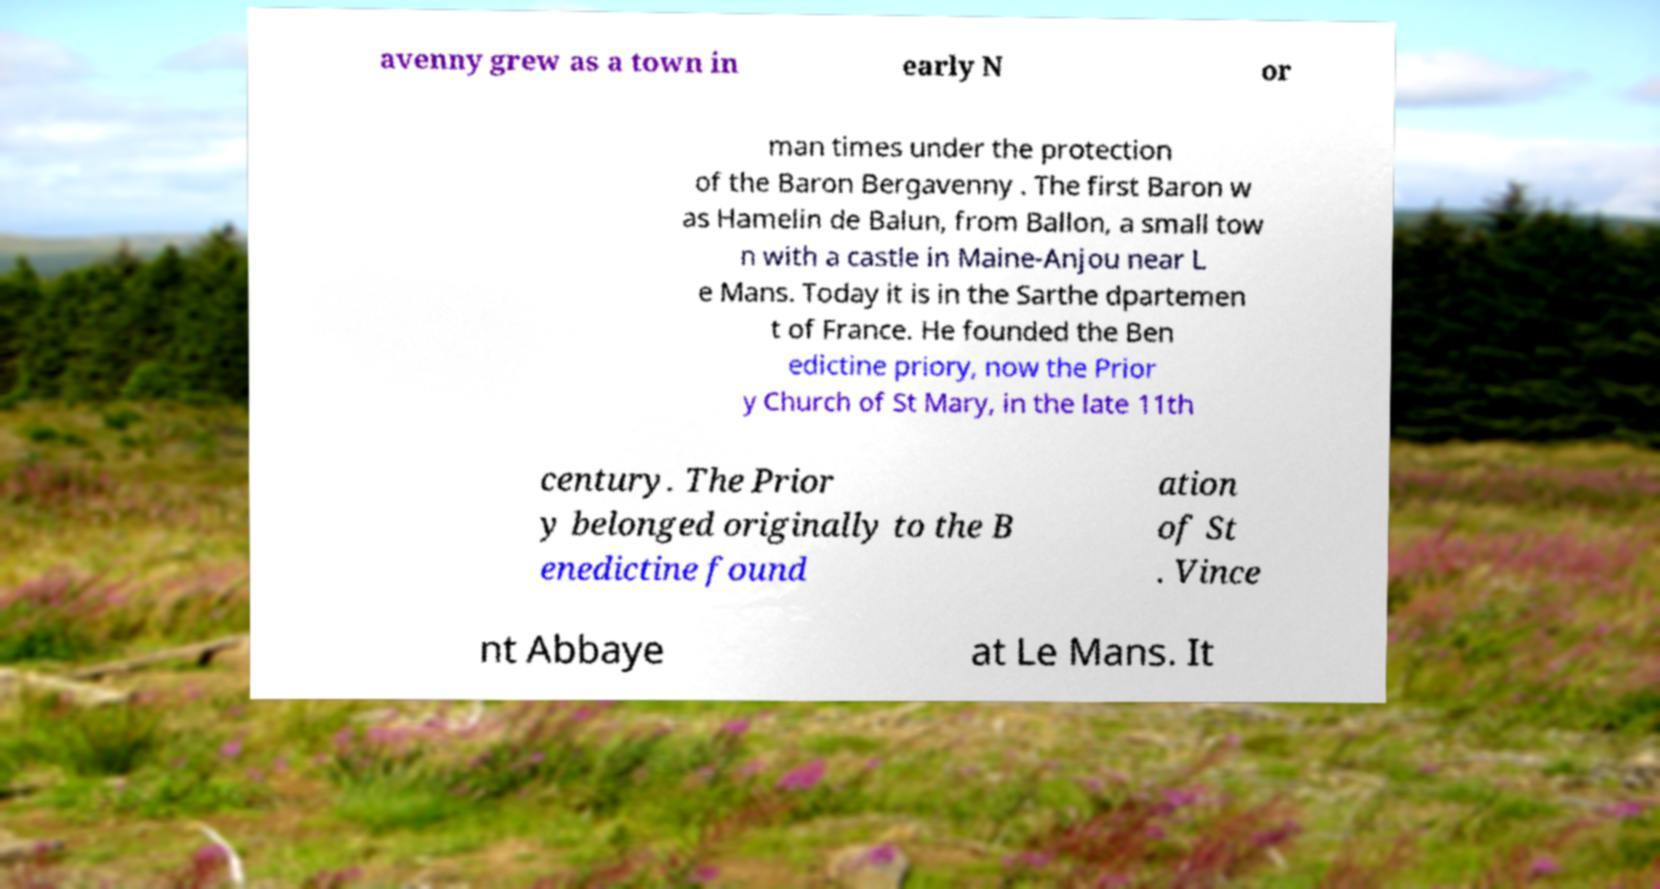Please identify and transcribe the text found in this image. avenny grew as a town in early N or man times under the protection of the Baron Bergavenny . The first Baron w as Hamelin de Balun, from Ballon, a small tow n with a castle in Maine-Anjou near L e Mans. Today it is in the Sarthe dpartemen t of France. He founded the Ben edictine priory, now the Prior y Church of St Mary, in the late 11th century. The Prior y belonged originally to the B enedictine found ation of St . Vince nt Abbaye at Le Mans. It 